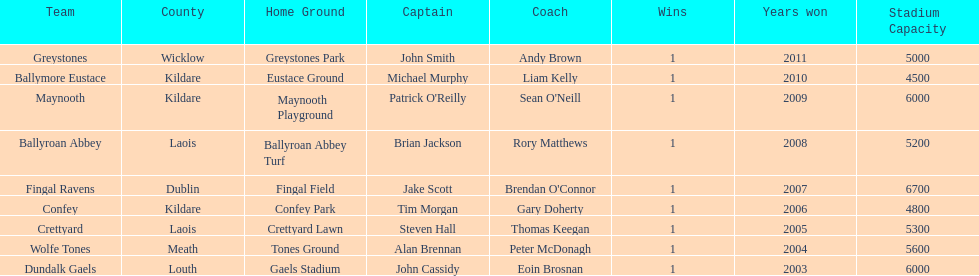Which county had the most number of wins? Kildare. 